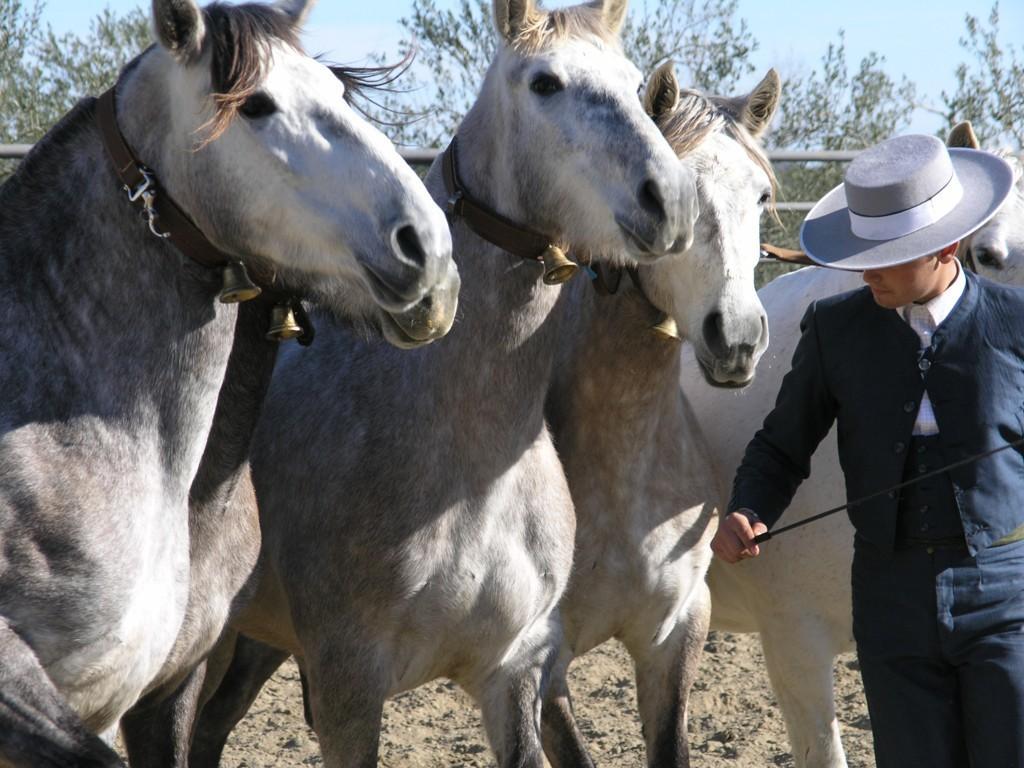Please provide a concise description of this image. In this image I see 5 horses in which these 4 are of white and grey in color and this horse is of white in color and I see a man over here who is wearing a white hat and holding a black color thing in his hand and I see that he is wearing blue color dress. In the background I see the rods, trees, sky and I see the mud. 